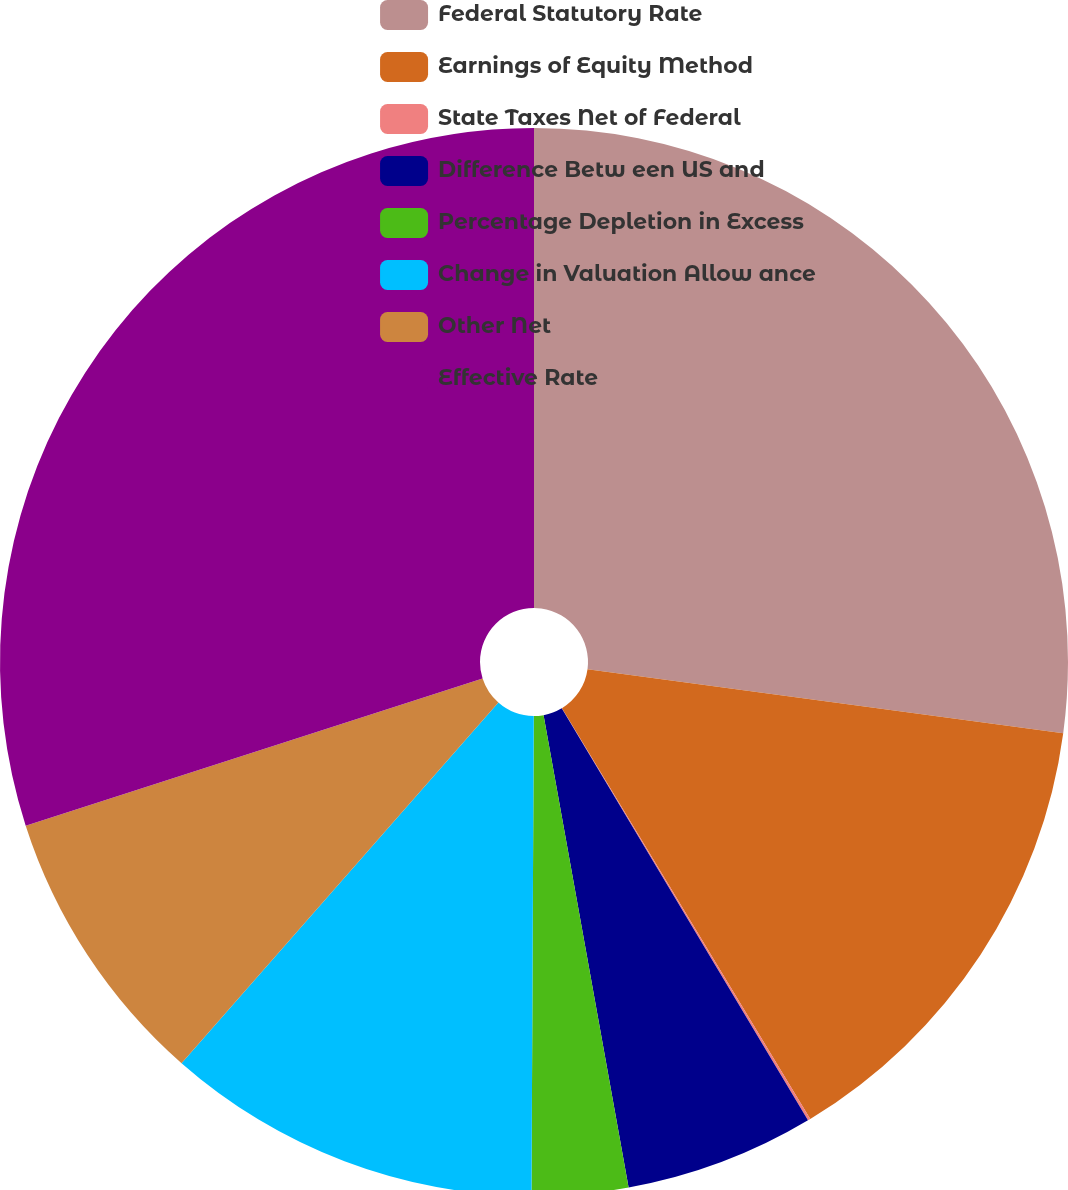<chart> <loc_0><loc_0><loc_500><loc_500><pie_chart><fcel>Federal Statutory Rate<fcel>Earnings of Equity Method<fcel>State Taxes Net of Federal<fcel>Difference Betw een US and<fcel>Percentage Depletion in Excess<fcel>Change in Valuation Allow ance<fcel>Other Net<fcel>Effective Rate<nl><fcel>27.13%<fcel>14.22%<fcel>0.08%<fcel>5.74%<fcel>2.91%<fcel>11.4%<fcel>8.57%<fcel>29.96%<nl></chart> 